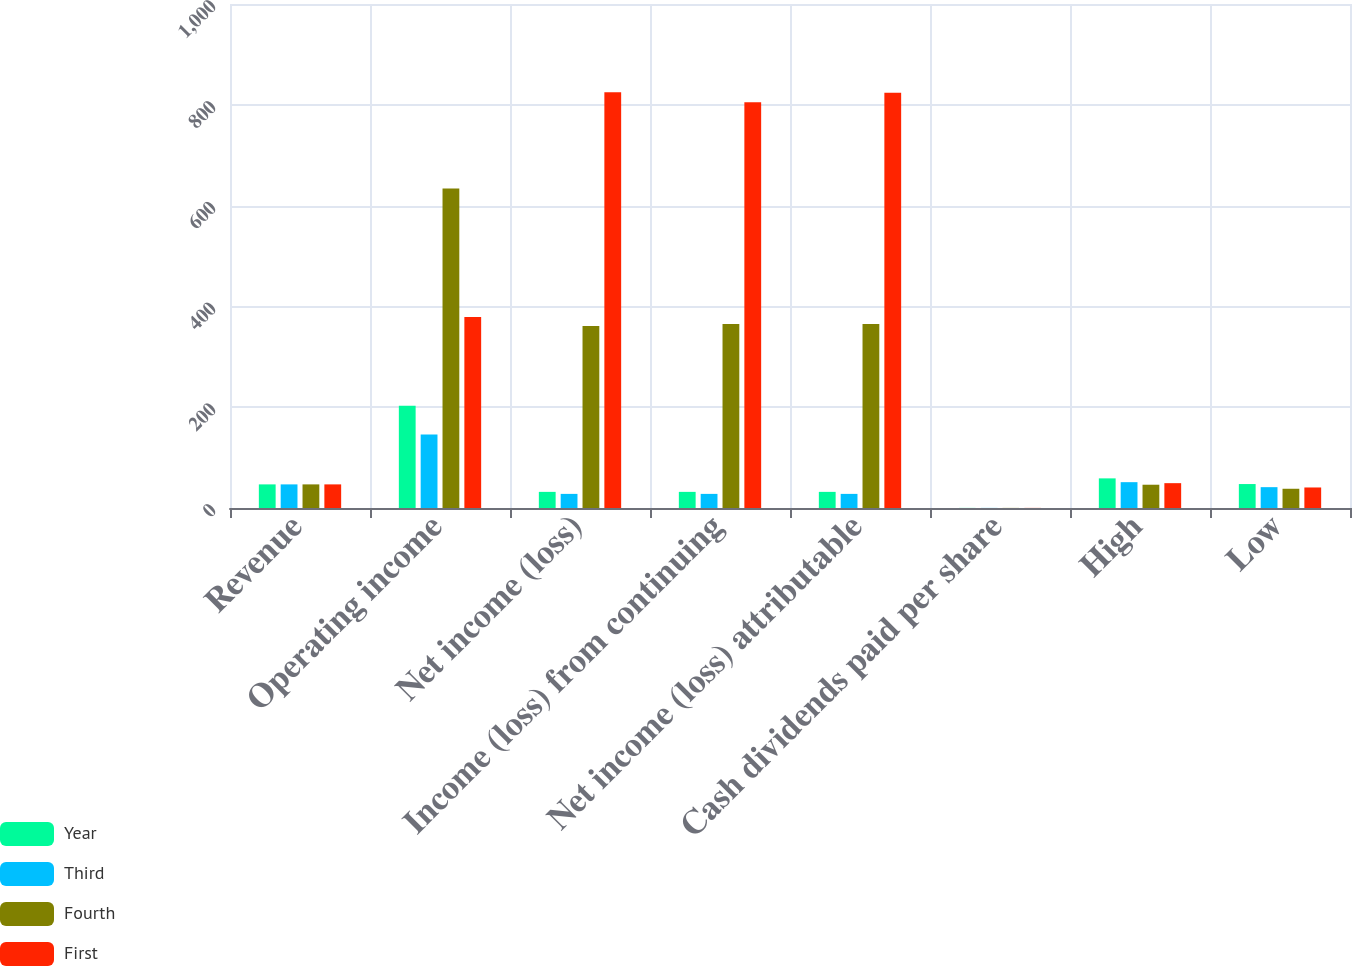Convert chart to OTSL. <chart><loc_0><loc_0><loc_500><loc_500><stacked_bar_chart><ecel><fcel>Revenue<fcel>Operating income<fcel>Net income (loss)<fcel>Income (loss) from continuing<fcel>Net income (loss) attributable<fcel>Cash dividends paid per share<fcel>High<fcel>Low<nl><fcel>Year<fcel>46.85<fcel>203<fcel>32<fcel>32<fcel>32<fcel>0.18<fcel>58.78<fcel>47.52<nl><fcel>Third<fcel>46.85<fcel>146<fcel>28<fcel>28<fcel>28<fcel>0.18<fcel>51.26<fcel>41.36<nl><fcel>Fourth<fcel>46.85<fcel>634<fcel>361<fcel>365<fcel>365<fcel>0.18<fcel>46.18<fcel>38.18<nl><fcel>First<fcel>46.85<fcel>379<fcel>825<fcel>805<fcel>824<fcel>0.18<fcel>49.29<fcel>40.72<nl></chart> 